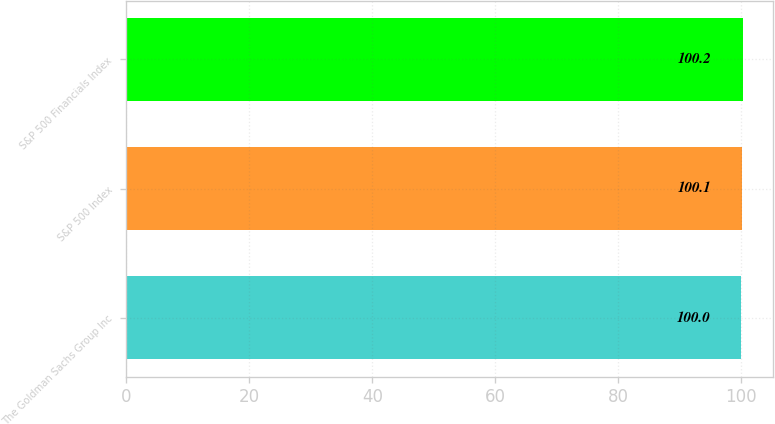<chart> <loc_0><loc_0><loc_500><loc_500><bar_chart><fcel>The Goldman Sachs Group Inc<fcel>S&P 500 Index<fcel>S&P 500 Financials Index<nl><fcel>100<fcel>100.1<fcel>100.2<nl></chart> 